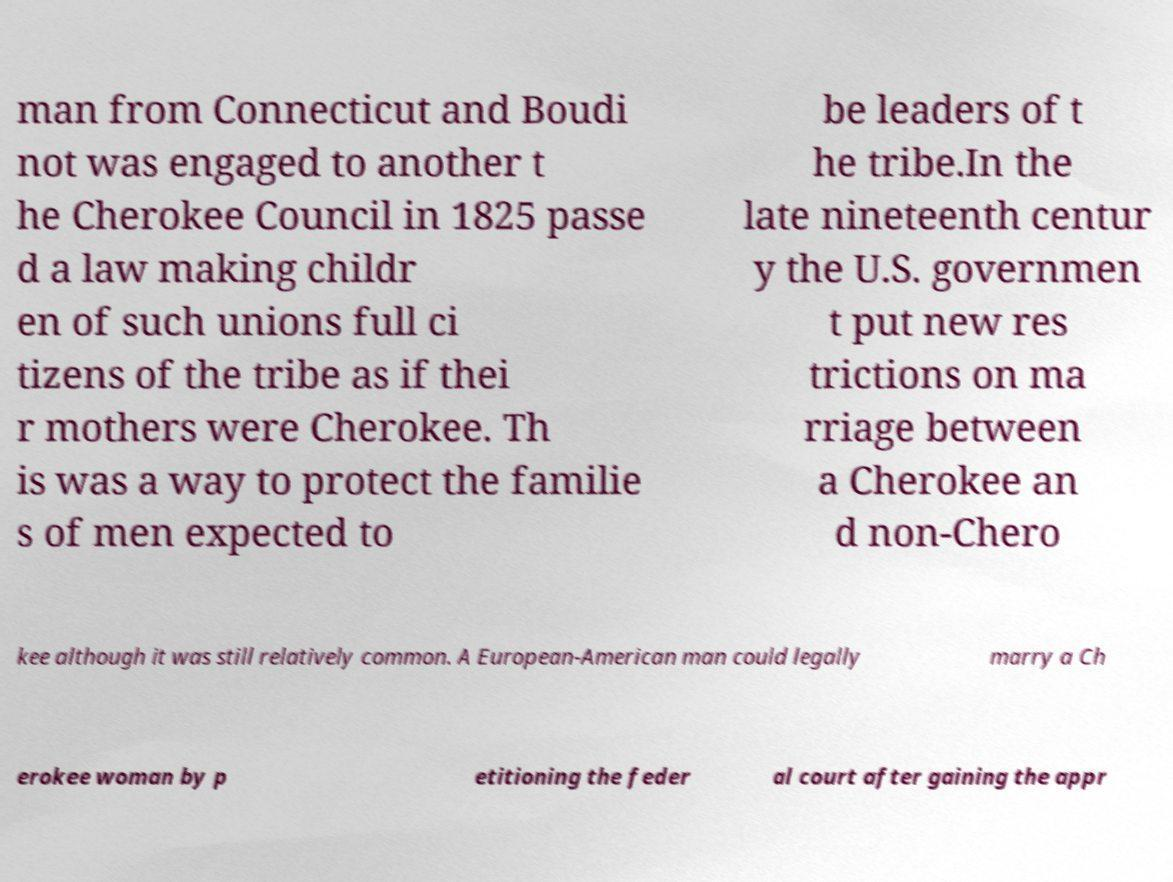I need the written content from this picture converted into text. Can you do that? man from Connecticut and Boudi not was engaged to another t he Cherokee Council in 1825 passe d a law making childr en of such unions full ci tizens of the tribe as if thei r mothers were Cherokee. Th is was a way to protect the familie s of men expected to be leaders of t he tribe.In the late nineteenth centur y the U.S. governmen t put new res trictions on ma rriage between a Cherokee an d non-Chero kee although it was still relatively common. A European-American man could legally marry a Ch erokee woman by p etitioning the feder al court after gaining the appr 